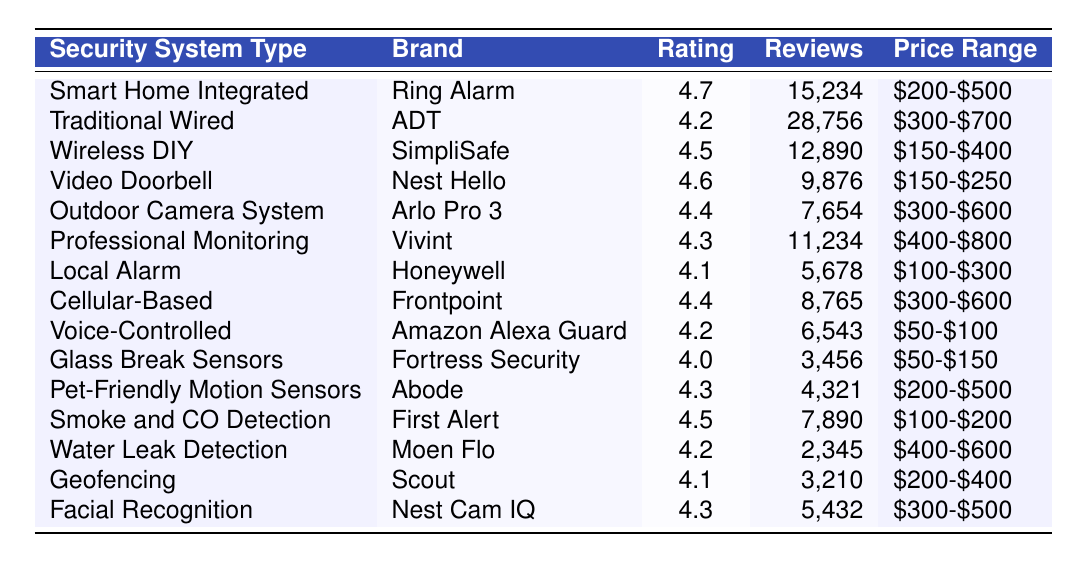What is the customer satisfaction rating of the Smart Home Integrated security system? From the table, the Smart Home Integrated security system (Ring Alarm) has a customer satisfaction rating of 4.7.
Answer: 4.7 Which security system type has the highest number of reviews? The Traditional Wired security system (ADT) has the highest number of reviews with 28,756.
Answer: Traditional Wired What is the price range for the Wireless DIY security system? According to the table, the price range for the Wireless DIY security system (SimpliSafe) is $150-$400.
Answer: $150-$400 Which brand offers a Video Doorbell security system? The table indicates that the Video Doorbell security system is offered by the brand Nest Hello.
Answer: Nest Hello Is the customer satisfaction rating for Cellular-Based security systems higher than 4.3? The satisfaction rating for Cellular-Based security systems (Frontpoint) is 4.4, which is higher than 4.3.
Answer: Yes What is the average customer satisfaction rating of all systems with a price range below $300? The systems with a price range below $300 are Voice-Controlled (4.2), Glass Break Sensors (4.0), and Local Alarm (4.1). The average is (4.2 + 4.0 + 4.1) / 3 = 4.133, approximately 4.1.
Answer: 4.1 How many reviews did the Outdoor Camera System receive? The table shows that the Outdoor Camera System (Arlo Pro 3) received 7,654 reviews.
Answer: 7,654 Which security system types have a customer satisfaction rating of 4.3 or higher? The following systems have a rating of 4.3 or higher: Smart Home Integrated (4.7), Wireless DIY (4.5), Video Doorbell (4.6), Cellular-Based (4.4), Professional Monitoring (4.3), Pet-Friendly Motion Sensors (4.3), Smoke and CO Detection (4.5), and Facial Recognition (4.3).
Answer: 8 systems What is the difference in customer satisfaction rating between the Glass Break Sensors and Pet-Friendly Motion Sensors? The Glass Break Sensors have a rating of 4.0 and Pet-Friendly Motion Sensors have a rating of 4.3. The difference is 4.3 - 4.0 = 0.3.
Answer: 0.3 Which type of security system has the lowest customer satisfaction rating, and what is that rating? The Glass Break Sensors have the lowest customer satisfaction rating at 4.0.
Answer: 4.0 